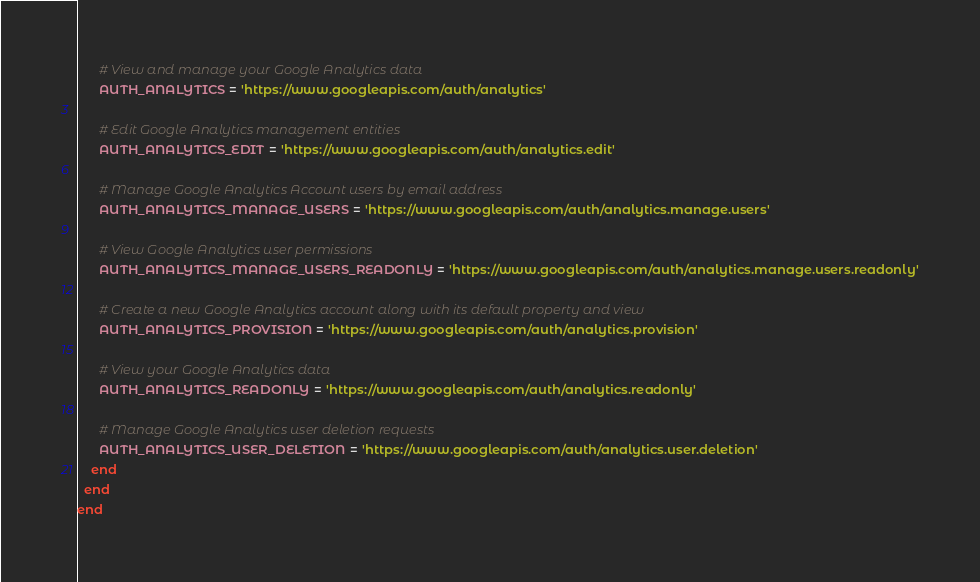<code> <loc_0><loc_0><loc_500><loc_500><_Ruby_>      # View and manage your Google Analytics data
      AUTH_ANALYTICS = 'https://www.googleapis.com/auth/analytics'

      # Edit Google Analytics management entities
      AUTH_ANALYTICS_EDIT = 'https://www.googleapis.com/auth/analytics.edit'

      # Manage Google Analytics Account users by email address
      AUTH_ANALYTICS_MANAGE_USERS = 'https://www.googleapis.com/auth/analytics.manage.users'

      # View Google Analytics user permissions
      AUTH_ANALYTICS_MANAGE_USERS_READONLY = 'https://www.googleapis.com/auth/analytics.manage.users.readonly'

      # Create a new Google Analytics account along with its default property and view
      AUTH_ANALYTICS_PROVISION = 'https://www.googleapis.com/auth/analytics.provision'

      # View your Google Analytics data
      AUTH_ANALYTICS_READONLY = 'https://www.googleapis.com/auth/analytics.readonly'

      # Manage Google Analytics user deletion requests
      AUTH_ANALYTICS_USER_DELETION = 'https://www.googleapis.com/auth/analytics.user.deletion'
    end
  end
end
</code> 